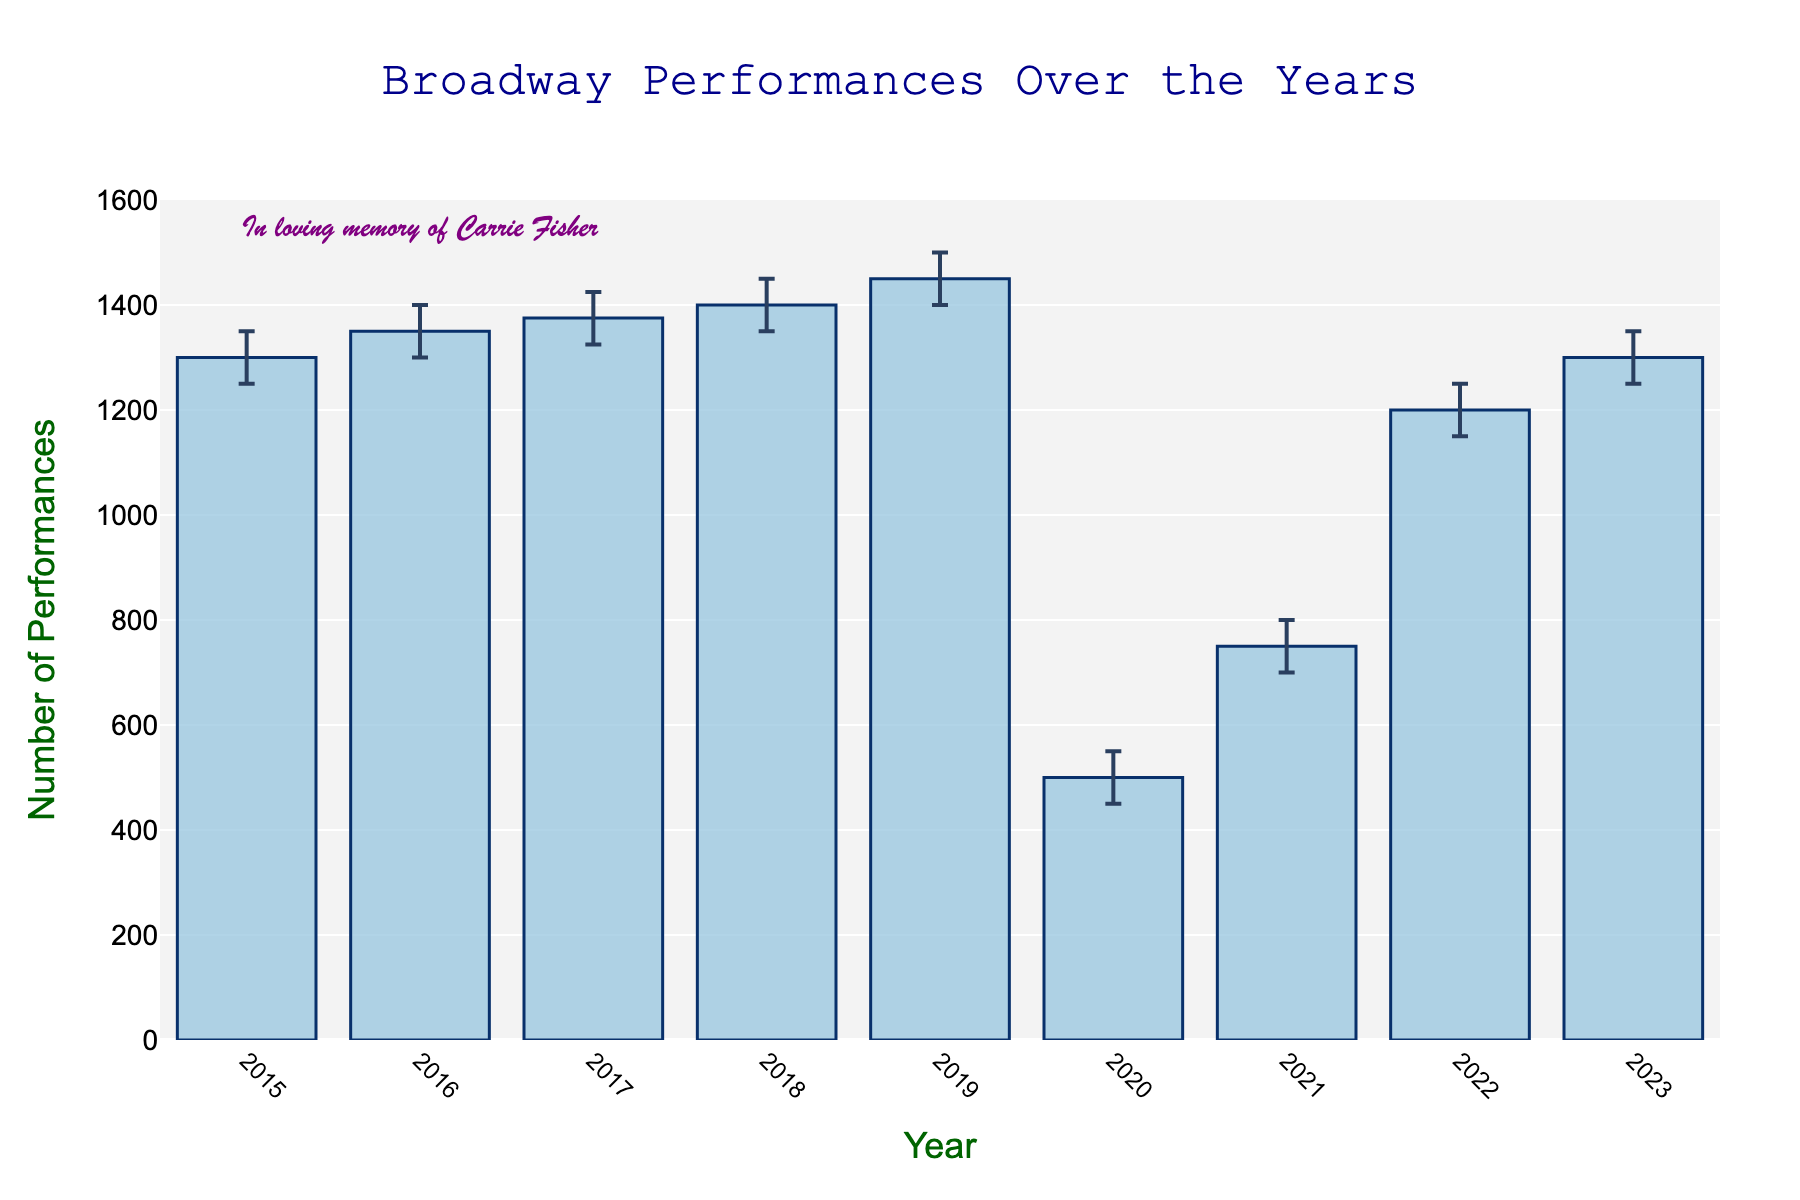What's the title of the figure? The title of the figure is centrally located above the plot in large font. It states the overall theme of the data presented.
Answer: Broadway Performances Over the Years What is the range of the y-axis? The y-axis range can be determined by looking at the minimum and maximum values marked on the y-axis.
Answer: 0 to 1600 How many years are displayed in the figure? The figure has bars for each year from 2015 to 2023. Counting the bars gives the total number of years displayed.
Answer: 9 What year had the lowest number of Broadway performances? By observing the height of the bars, the year 2020 clearly has the lowest bar, representing the lowest number of Broadway performances.
Answer: 2020 What is the mean number of performances in 2020? The mean number of performances is indicated by the height of the bar for the year 2020.
Answer: 500 In 2019, what are the values of the confidence interval? The confidence interval for 2019 can be found by looking at the error bars extending above and below the 2019 bar. The upper limit is 1500 and the lower limit is 1400.
Answer: 1400 to 1500 How did the number of Broadway performances change from 2019 to 2020? By comparing the heights of the bars for 2019 and 2020, there is a significant drop, with 2019 having 1450 performances and 2020 having only 500.
Answer: Decreased Which year had the largest confidence interval range? The largest confidence interval can be identified by comparing the lengths of the error bars across all years. The year with the longest total error bars (upper CI - lower CI) is 2017 (1425 - 1325 = 100).
Answer: 2017 What is written in the annotation? The annotation on the plot states a nostalgic message, located near the year 2016.
Answer: In loving memory of Carrie Fisher What is the approximate number of performances in 2023, including its confidence interval? The bar for 2023 shows the mean number of performances at 1300, with error bars extending from 1250 to 1350.
Answer: 1250 to 1350 